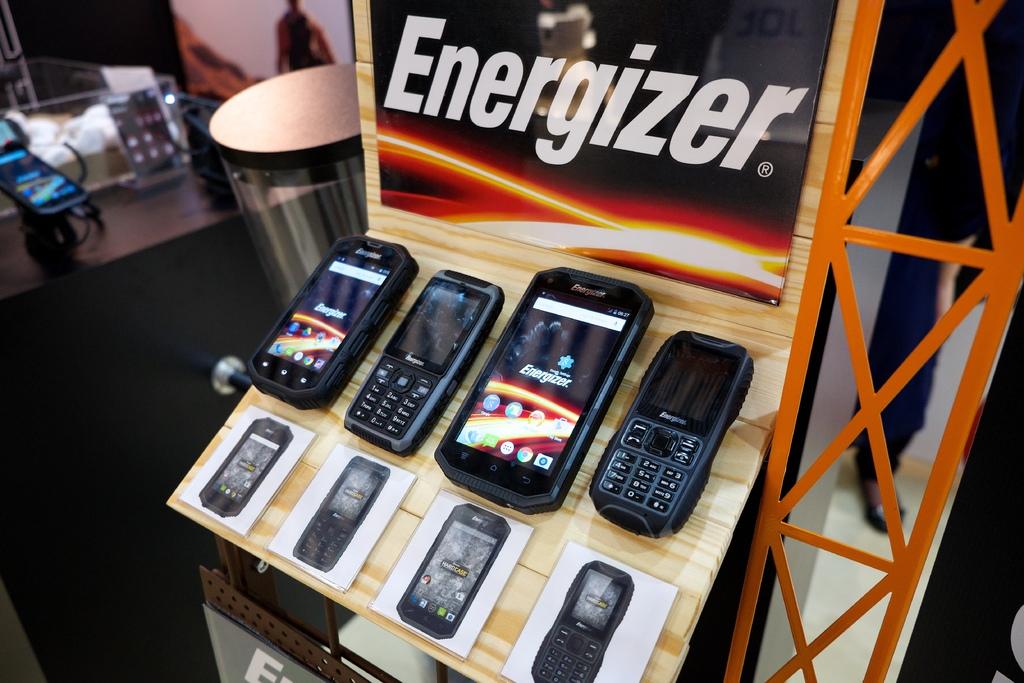What type of battery brand does the phone use?
Keep it short and to the point. Energizer. What kind of phone is on the right?
Keep it short and to the point. Energizer. 